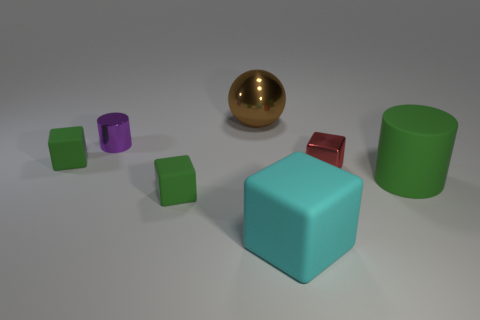What mood does the arrangement of objects convey? The arrangement seems methodical and tranquil, with objects neatly spaced, suggesting a sense of order and balance. 